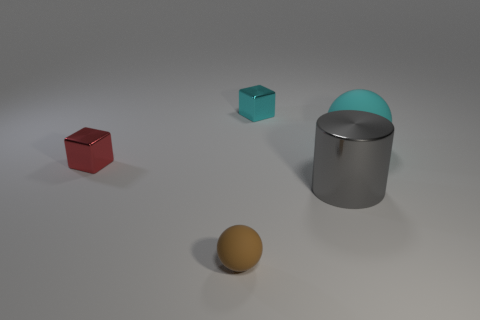Add 2 small green rubber blocks. How many objects exist? 7 Subtract all blocks. How many objects are left? 3 Subtract all brown things. Subtract all large rubber balls. How many objects are left? 3 Add 2 brown objects. How many brown objects are left? 3 Add 2 metallic cubes. How many metallic cubes exist? 4 Subtract 0 purple cylinders. How many objects are left? 5 